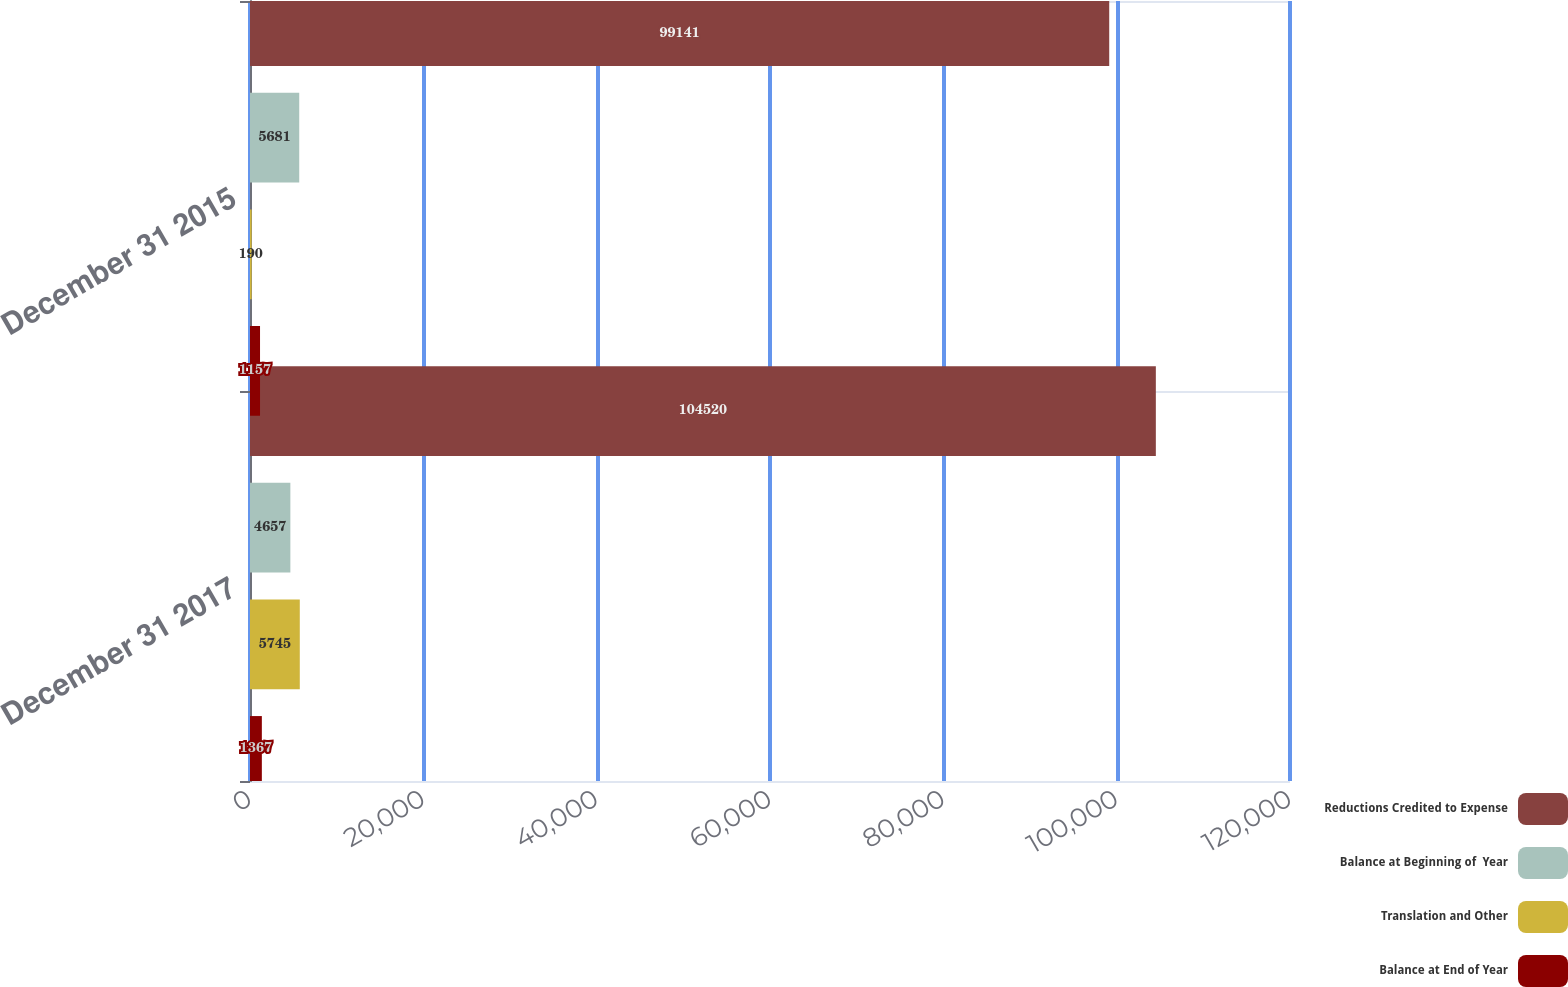Convert chart. <chart><loc_0><loc_0><loc_500><loc_500><stacked_bar_chart><ecel><fcel>December 31 2017<fcel>December 31 2015<nl><fcel>Reductions Credited to Expense<fcel>104520<fcel>99141<nl><fcel>Balance at Beginning of  Year<fcel>4657<fcel>5681<nl><fcel>Translation and Other<fcel>5745<fcel>190<nl><fcel>Balance at End of Year<fcel>1367<fcel>1157<nl></chart> 